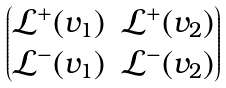Convert formula to latex. <formula><loc_0><loc_0><loc_500><loc_500>\begin{pmatrix} \mathcal { L } ^ { + } ( v _ { 1 } ) & \mathcal { L } ^ { + } ( v _ { 2 } ) \\ \mathcal { L } ^ { - } ( v _ { 1 } ) & \mathcal { L } ^ { - } ( v _ { 2 } ) \end{pmatrix}</formula> 